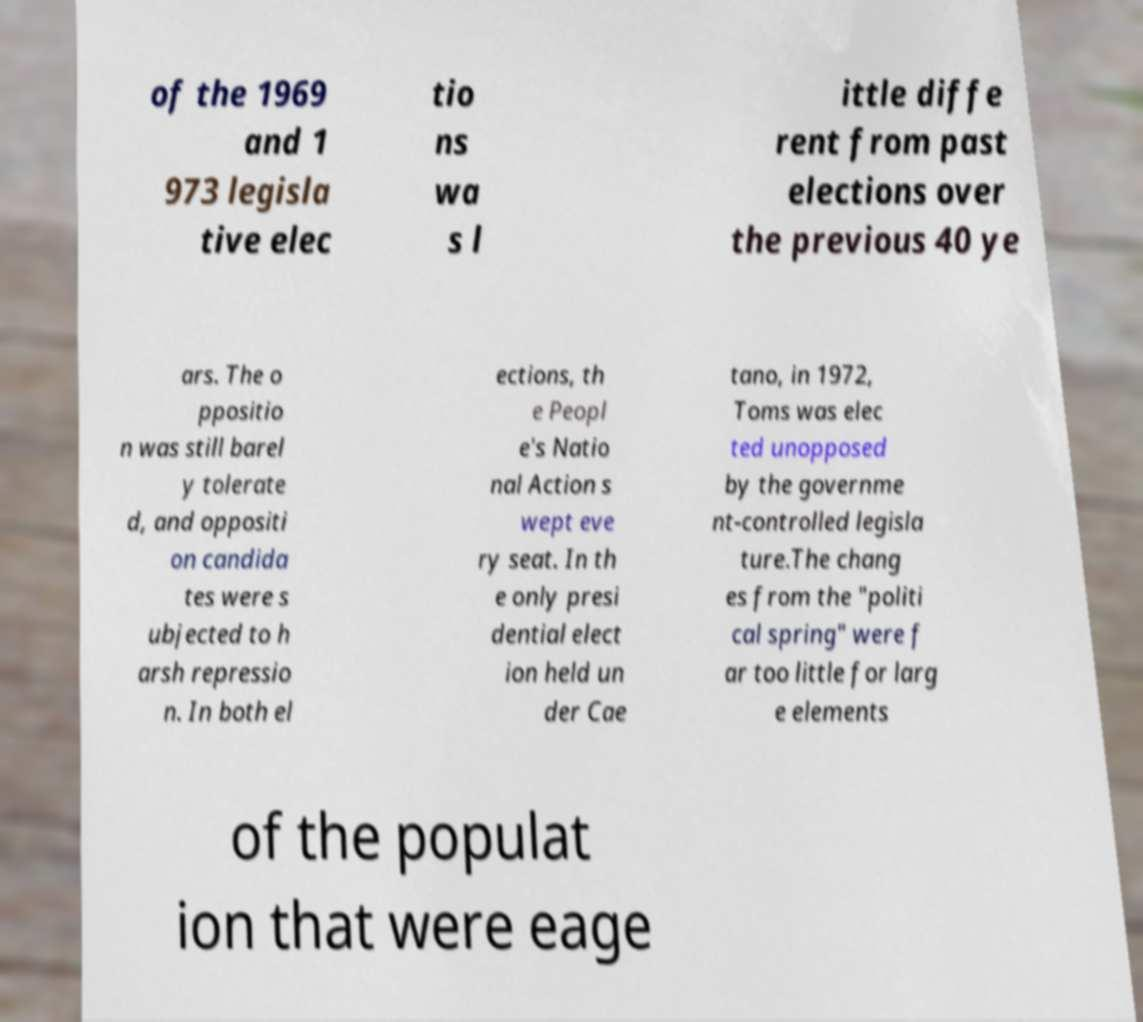I need the written content from this picture converted into text. Can you do that? of the 1969 and 1 973 legisla tive elec tio ns wa s l ittle diffe rent from past elections over the previous 40 ye ars. The o ppositio n was still barel y tolerate d, and oppositi on candida tes were s ubjected to h arsh repressio n. In both el ections, th e Peopl e's Natio nal Action s wept eve ry seat. In th e only presi dential elect ion held un der Cae tano, in 1972, Toms was elec ted unopposed by the governme nt-controlled legisla ture.The chang es from the "politi cal spring" were f ar too little for larg e elements of the populat ion that were eage 